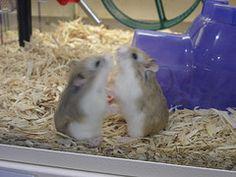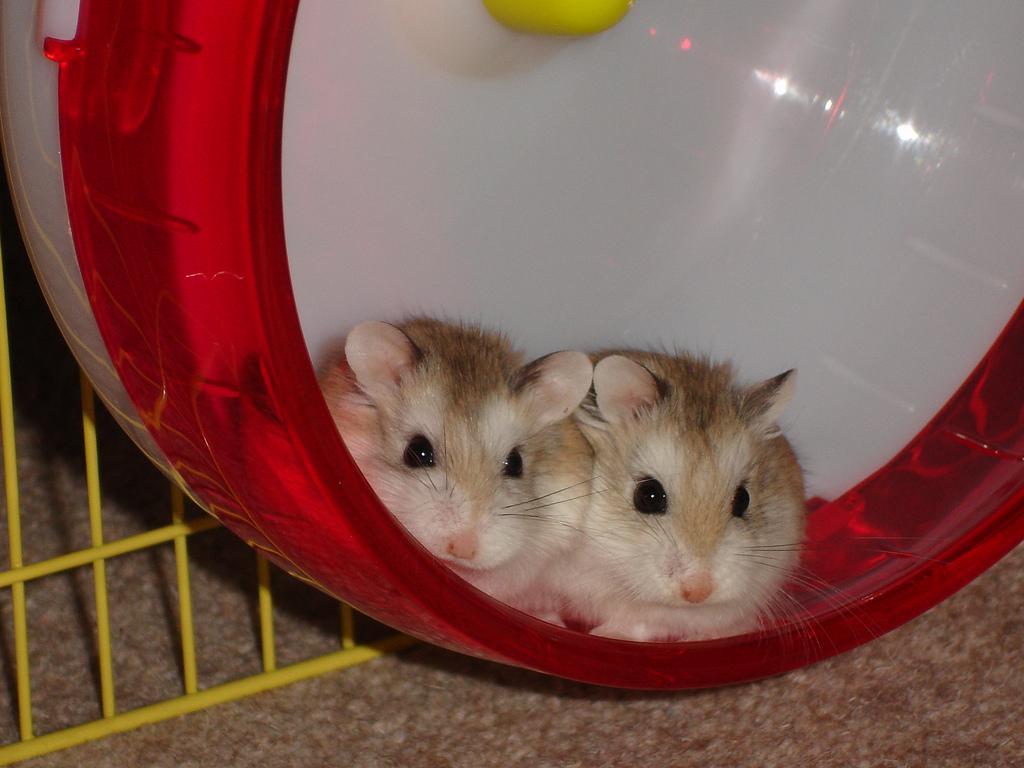The first image is the image on the left, the second image is the image on the right. Considering the images on both sides, is "Each image shows exactly two rodents." valid? Answer yes or no. Yes. The first image is the image on the left, the second image is the image on the right. For the images shown, is this caption "Every hamster is inside a wheel, and every hamster wheel is bright blue." true? Answer yes or no. No. 